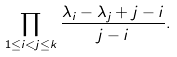<formula> <loc_0><loc_0><loc_500><loc_500>\prod _ { 1 \leq i < j \leq k } \frac { \lambda _ { i } - \lambda _ { j } + j - i } { j - i } .</formula> 